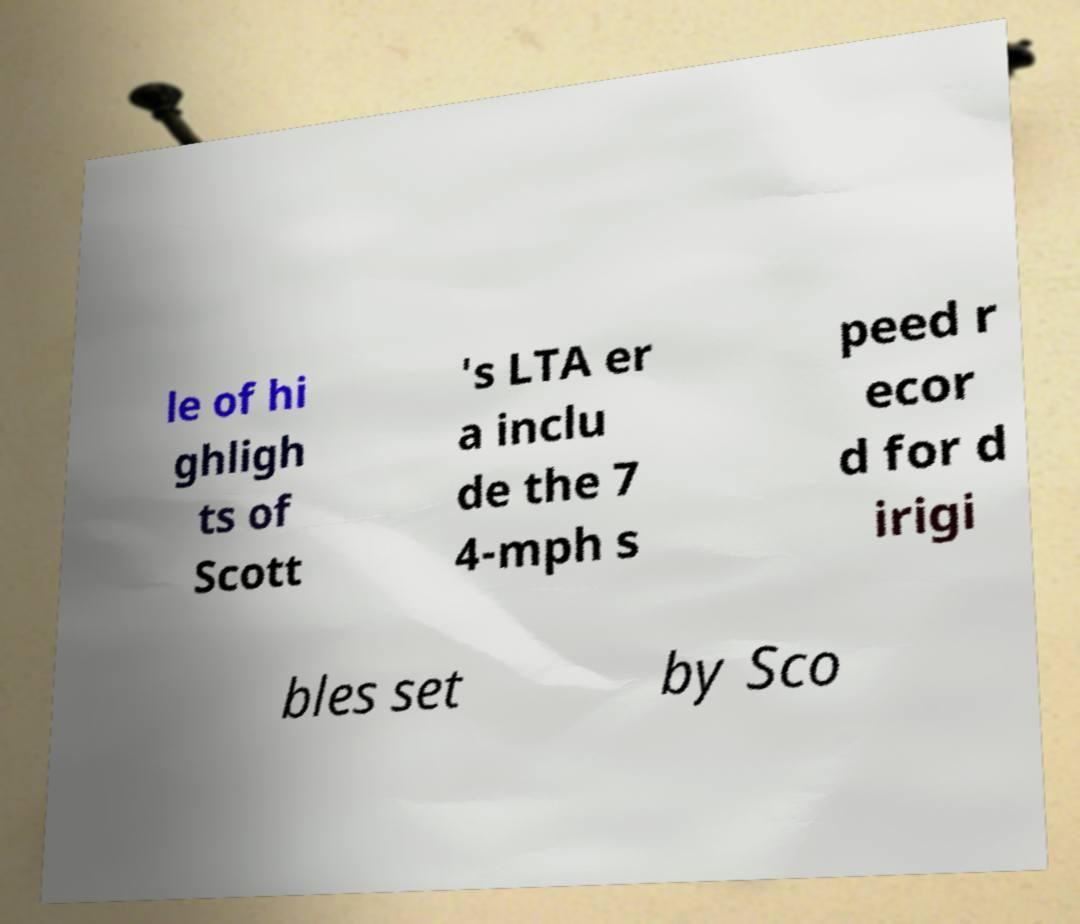Please read and relay the text visible in this image. What does it say? le of hi ghligh ts of Scott 's LTA er a inclu de the 7 4-mph s peed r ecor d for d irigi bles set by Sco 